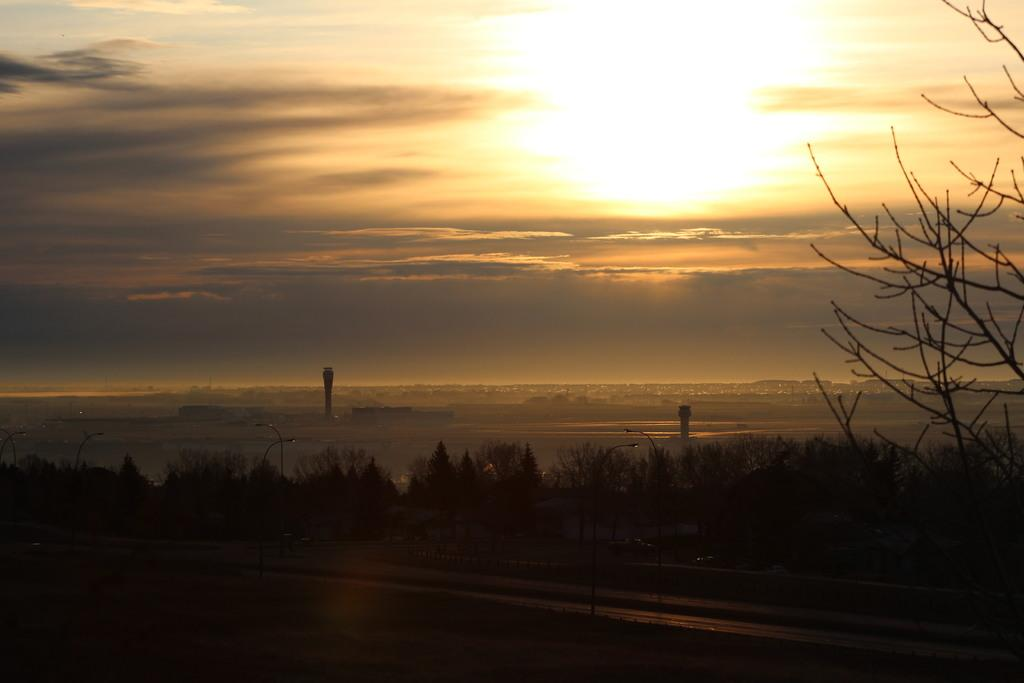What is located at the front of the image? There is a road in the front of the image. What can be seen in the center of the image? There are plants in the center of the image. What is visible in the background of the image? Water is visible in the background of the image. How would you describe the sky in the image? The sky is cloudy in the image. What is the condition of the tree on the right side of the image? There is a dry tree on the right side of the image. What type of twig is being used to measure the reaction of the water in the image? There is no twig or measurement of any reaction in the image. How can someone join the plants in the center of the image? There is no indication in the image that someone can join the plants, as they are not depicted as being part of a group or activity. 